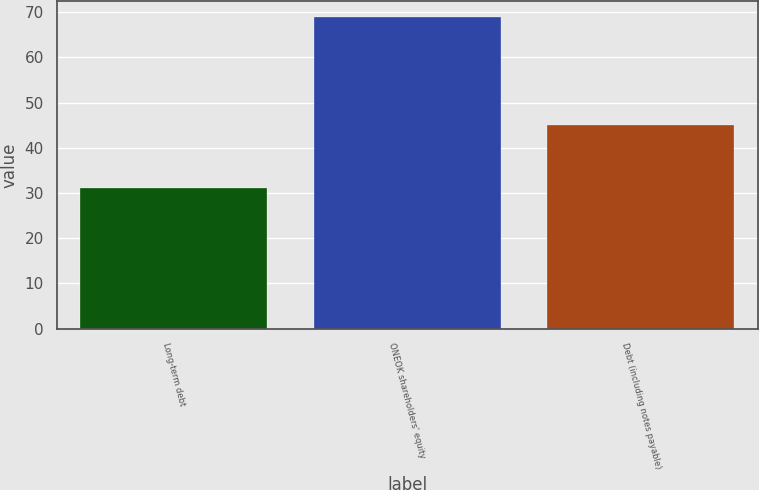Convert chart. <chart><loc_0><loc_0><loc_500><loc_500><bar_chart><fcel>Long-term debt<fcel>ONEOK shareholders' equity<fcel>Debt (including notes payable)<nl><fcel>31<fcel>69<fcel>45<nl></chart> 